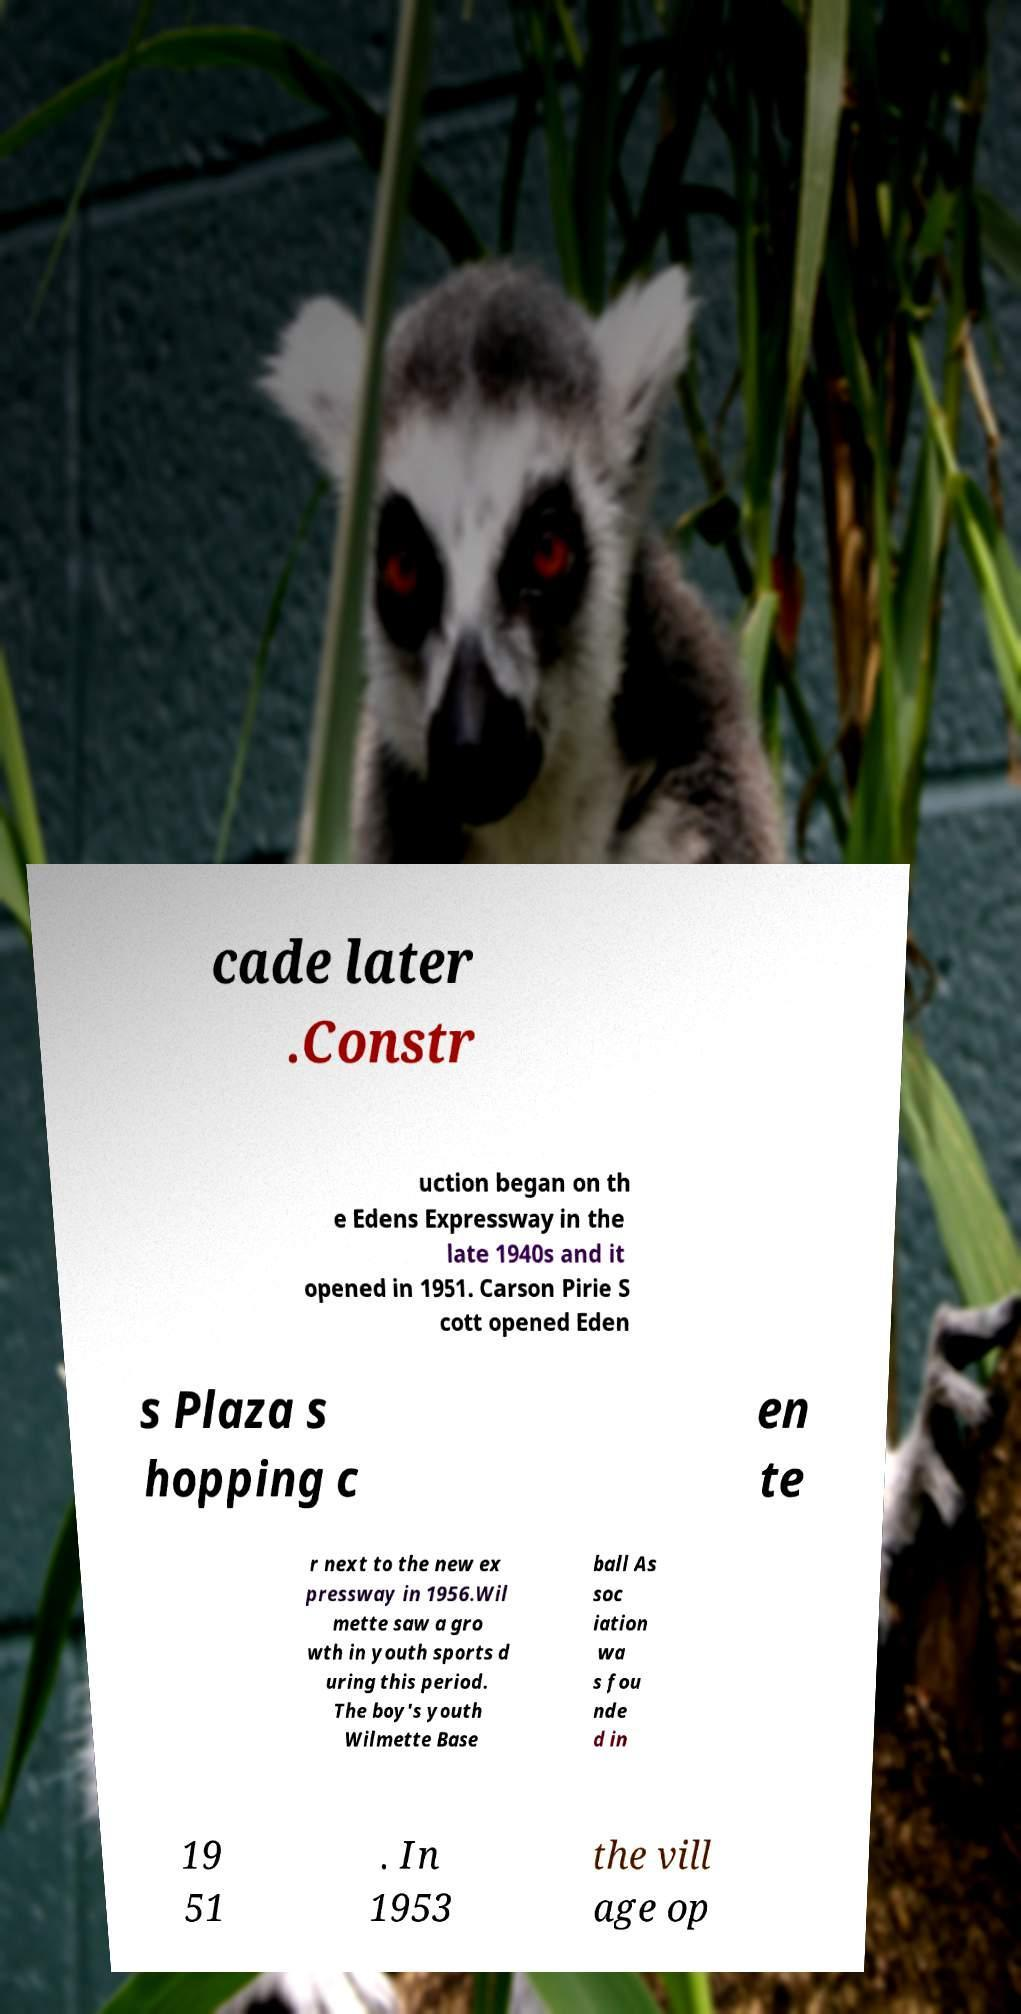Could you extract and type out the text from this image? cade later .Constr uction began on th e Edens Expressway in the late 1940s and it opened in 1951. Carson Pirie S cott opened Eden s Plaza s hopping c en te r next to the new ex pressway in 1956.Wil mette saw a gro wth in youth sports d uring this period. The boy's youth Wilmette Base ball As soc iation wa s fou nde d in 19 51 . In 1953 the vill age op 